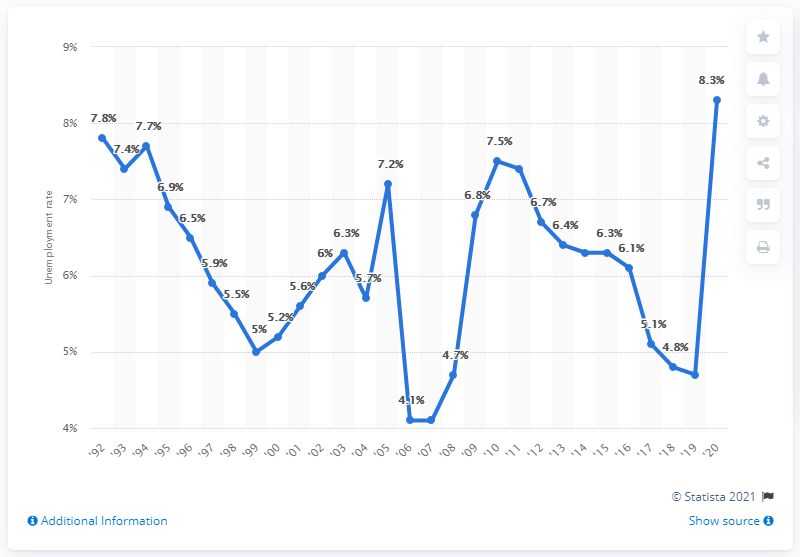Specify some key components in this picture. In 2020, the unemployment rate in Louisiana was 8.3%. The unemployment rate in Louisiana was previously 4.7%. 